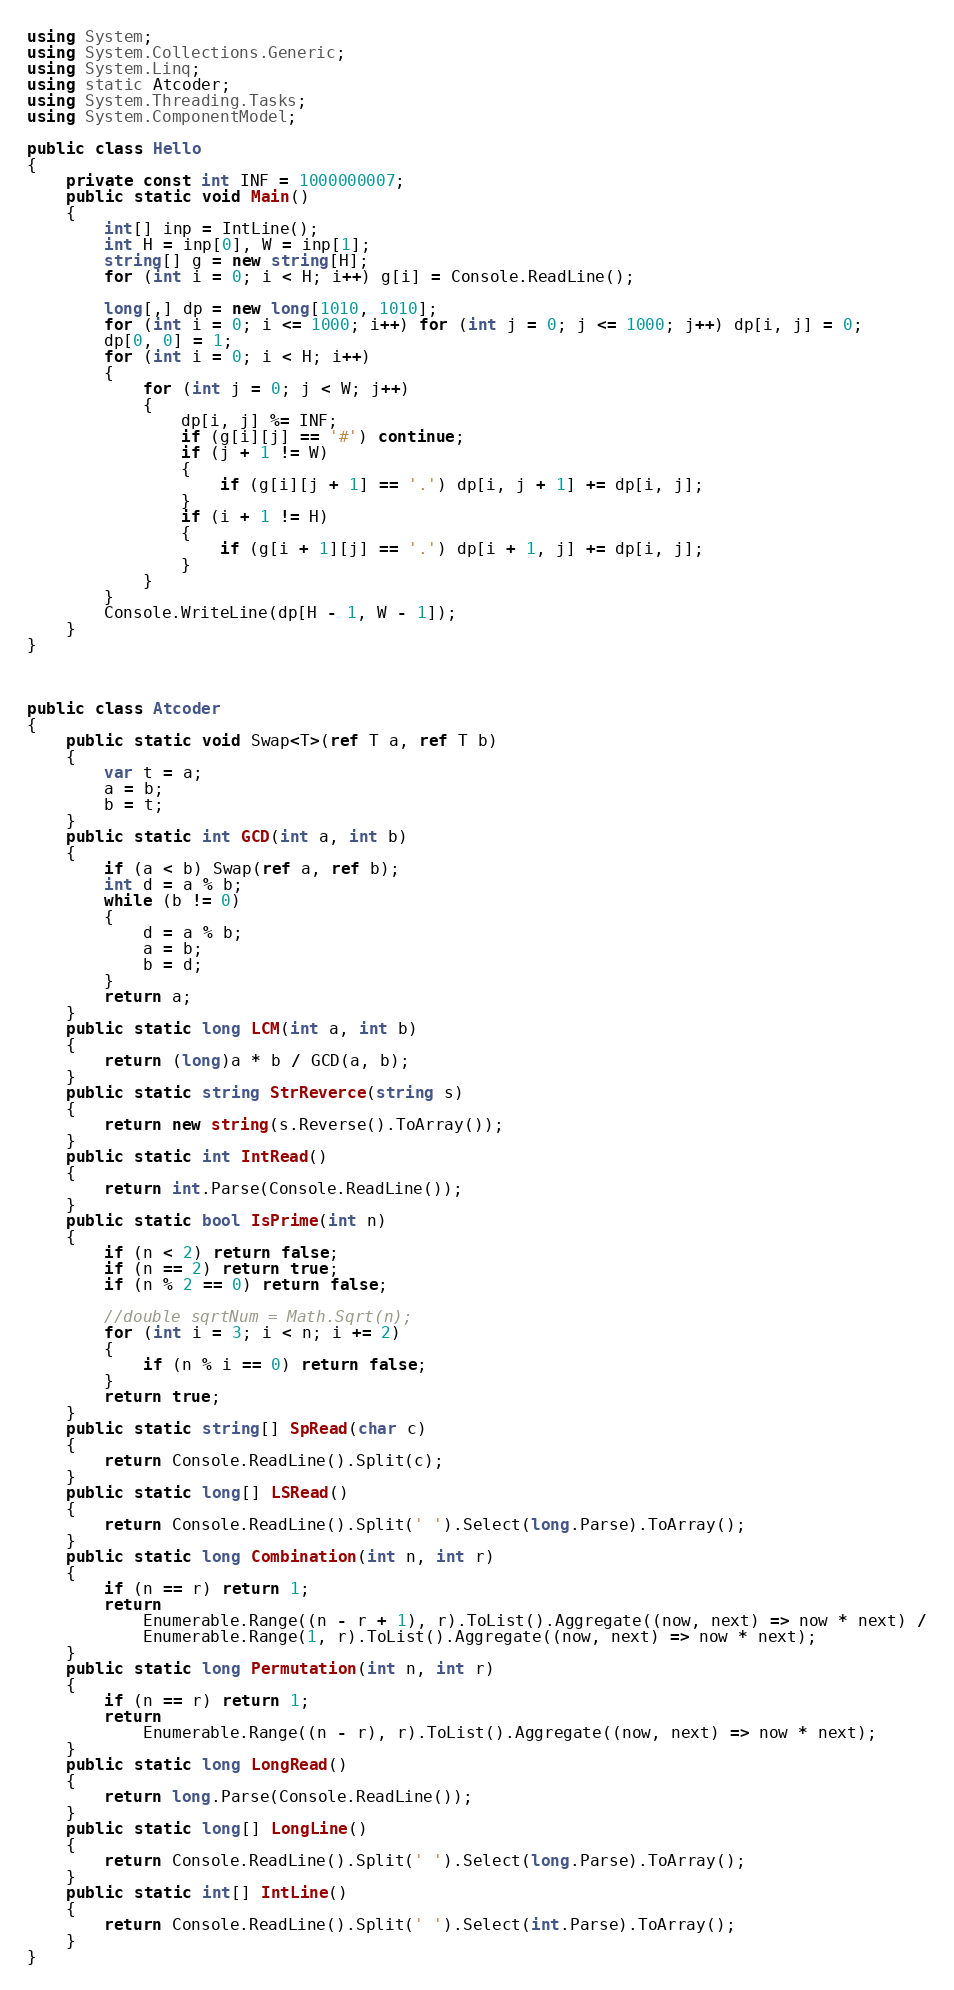Convert code to text. <code><loc_0><loc_0><loc_500><loc_500><_C#_>using System;
using System.Collections.Generic;
using System.Linq;
using static Atcoder;
using System.Threading.Tasks;
using System.ComponentModel;

public class Hello
{
    private const int INF = 1000000007;
    public static void Main()
    {
        int[] inp = IntLine();
        int H = inp[0], W = inp[1];
        string[] g = new string[H];
        for (int i = 0; i < H; i++) g[i] = Console.ReadLine();

        long[,] dp = new long[1010, 1010];
        for (int i = 0; i <= 1000; i++) for (int j = 0; j <= 1000; j++) dp[i, j] = 0;
        dp[0, 0] = 1;
        for (int i = 0; i < H; i++)
        {
            for (int j = 0; j < W; j++)
            {
                dp[i, j] %= INF;
                if (g[i][j] == '#') continue;
                if (j + 1 != W)
                {
                    if (g[i][j + 1] == '.') dp[i, j + 1] += dp[i, j];
                }
                if (i + 1 != H)
                {
                    if (g[i + 1][j] == '.') dp[i + 1, j] += dp[i, j];
                }
            }
        }
        Console.WriteLine(dp[H - 1, W - 1]);
    }
}



public class Atcoder
{
    public static void Swap<T>(ref T a, ref T b)
    {
        var t = a;
        a = b;
        b = t;
    }
    public static int GCD(int a, int b)
    {
        if (a < b) Swap(ref a, ref b);
        int d = a % b;
        while (b != 0)
        {
            d = a % b;
            a = b;
            b = d;
        }
        return a;
    }
    public static long LCM(int a, int b)
    {
        return (long)a * b / GCD(a, b);
    }
    public static string StrReverce(string s)
    {
        return new string(s.Reverse().ToArray());
    }
    public static int IntRead()
    {
        return int.Parse(Console.ReadLine());
    }
    public static bool IsPrime(int n)
    {
        if (n < 2) return false;
        if (n == 2) return true;
        if (n % 2 == 0) return false;

        //double sqrtNum = Math.Sqrt(n);
        for (int i = 3; i < n; i += 2)
        {
            if (n % i == 0) return false;
        }
        return true;
    }
    public static string[] SpRead(char c)
    {
        return Console.ReadLine().Split(c);
    }
    public static long[] LSRead()
    {
        return Console.ReadLine().Split(' ').Select(long.Parse).ToArray();
    }
    public static long Combination(int n, int r)
    {
        if (n == r) return 1;
        return
            Enumerable.Range((n - r + 1), r).ToList().Aggregate((now, next) => now * next) /
            Enumerable.Range(1, r).ToList().Aggregate((now, next) => now * next);
    }
    public static long Permutation(int n, int r)
    {
        if (n == r) return 1;
        return
            Enumerable.Range((n - r), r).ToList().Aggregate((now, next) => now * next);
    }
    public static long LongRead()
    {
        return long.Parse(Console.ReadLine());
    }
    public static long[] LongLine()
    {
        return Console.ReadLine().Split(' ').Select(long.Parse).ToArray();
    }
    public static int[] IntLine()
    {
        return Console.ReadLine().Split(' ').Select(int.Parse).ToArray();
    }
}
</code> 